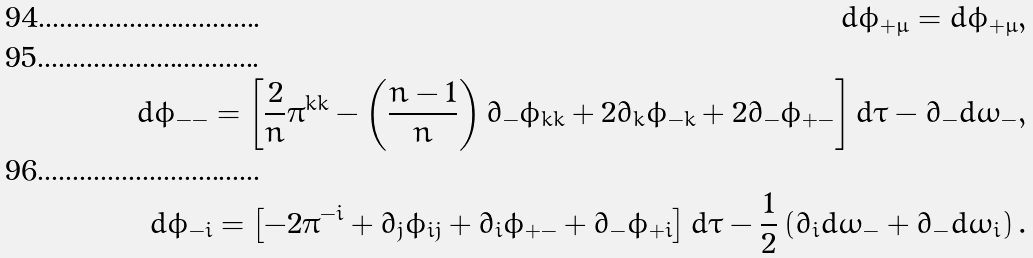<formula> <loc_0><loc_0><loc_500><loc_500>d \phi _ { + \mu } = d \phi _ { + \mu } , \\ d \phi _ { - - } = \left [ \frac { 2 } { n } \pi ^ { k k } - \left ( \frac { n - 1 } { n } \right ) \partial _ { - } \phi _ { k k } + 2 \partial _ { k } \phi _ { - k } + 2 \partial _ { - } \phi _ { + - } \right ] d \tau - \partial _ { - } d \omega _ { - } , \\ d \phi _ { - i } = \left [ - 2 \pi ^ { - i } + \partial _ { j } \phi _ { i j } + \partial _ { i } \phi _ { + - } + \partial _ { - } \phi _ { + i } \right ] d \tau - \frac { 1 } { 2 } \left ( \partial _ { i } d \omega _ { - } + \partial _ { - } d \omega _ { i } \right ) .</formula> 